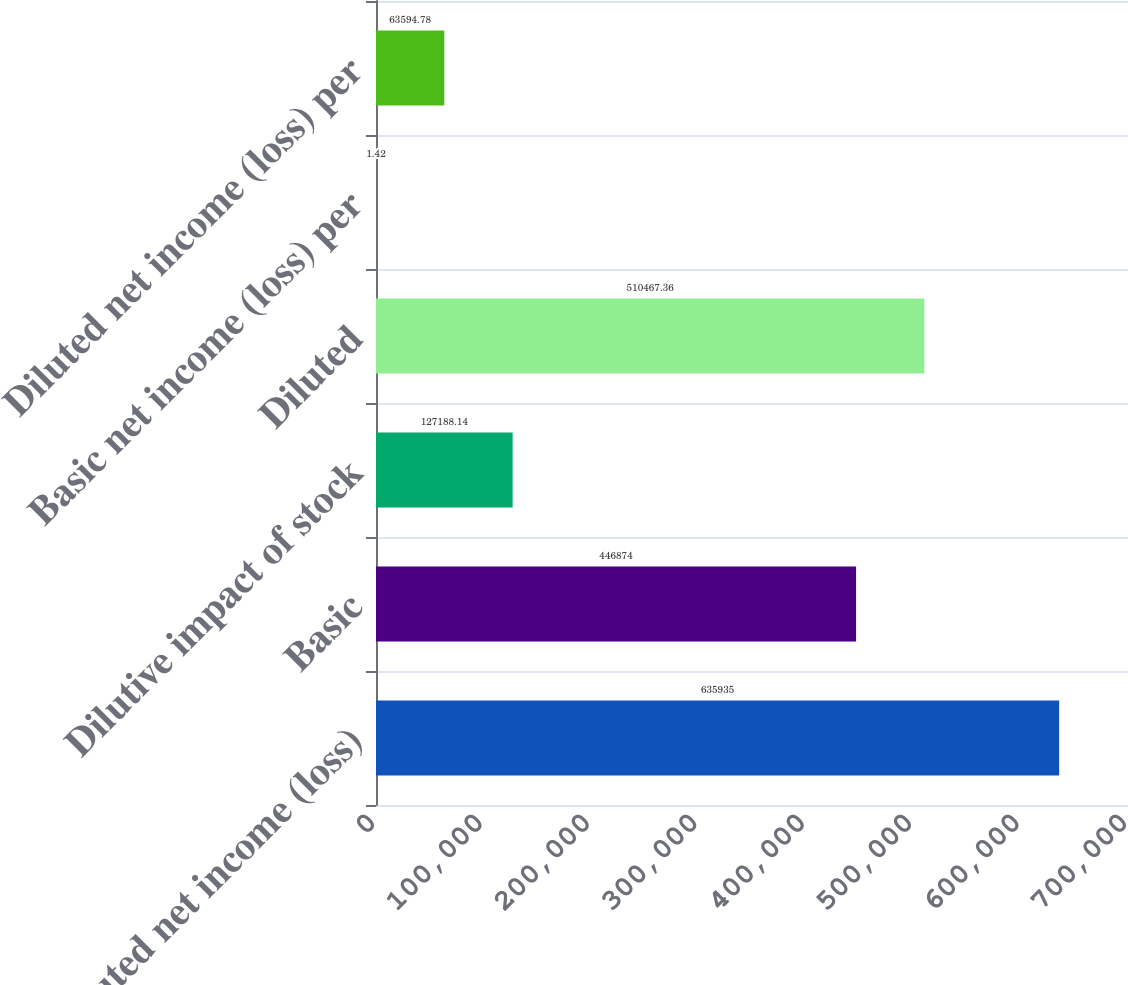Convert chart to OTSL. <chart><loc_0><loc_0><loc_500><loc_500><bar_chart><fcel>Diluted net income (loss)<fcel>Basic<fcel>Dilutive impact of stock<fcel>Diluted<fcel>Basic net income (loss) per<fcel>Diluted net income (loss) per<nl><fcel>635935<fcel>446874<fcel>127188<fcel>510467<fcel>1.42<fcel>63594.8<nl></chart> 